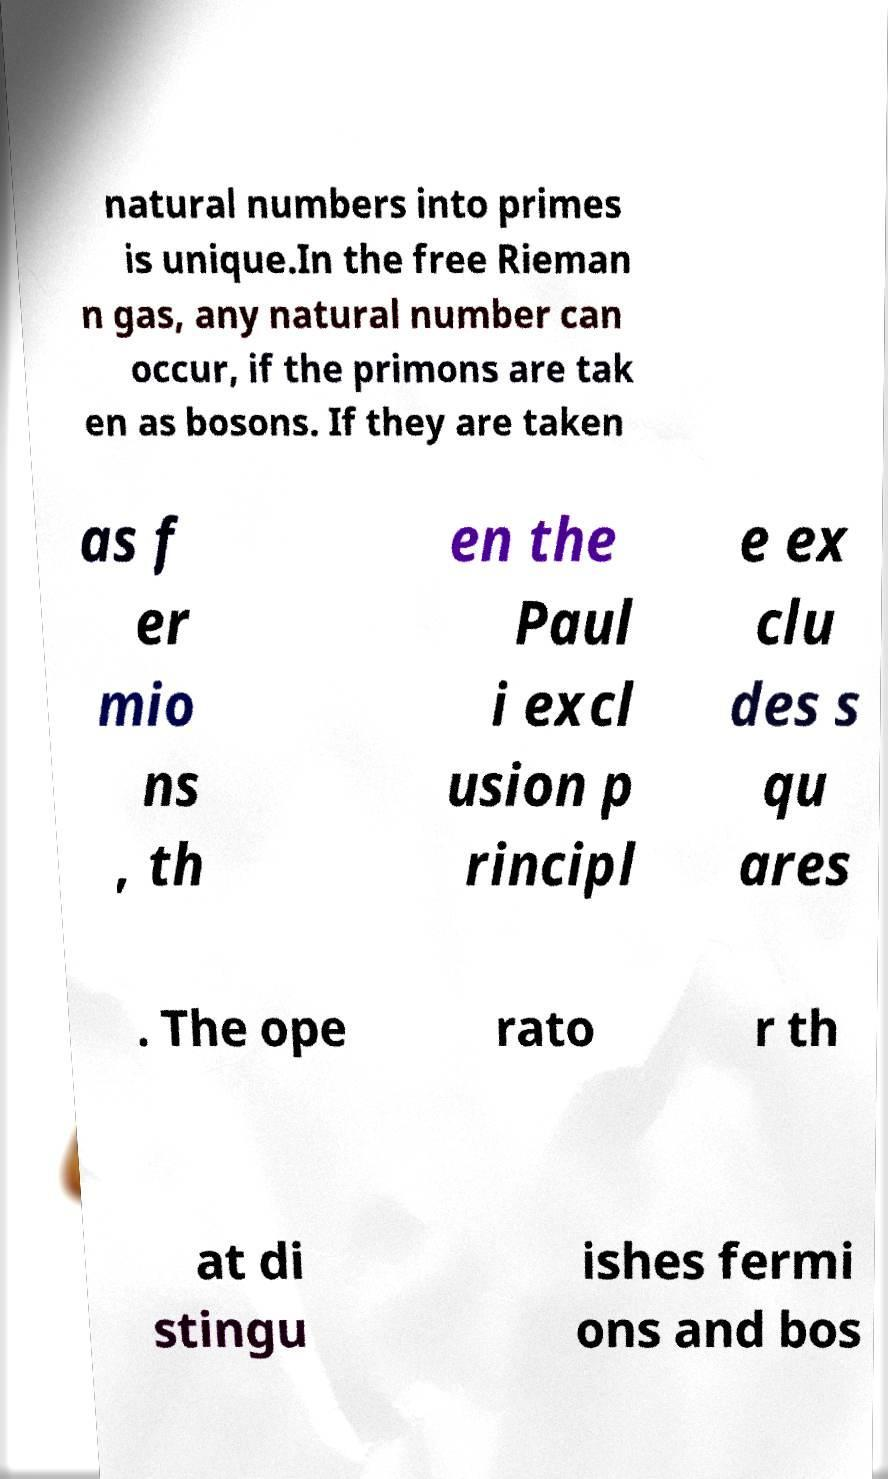What messages or text are displayed in this image? I need them in a readable, typed format. natural numbers into primes is unique.In the free Rieman n gas, any natural number can occur, if the primons are tak en as bosons. If they are taken as f er mio ns , th en the Paul i excl usion p rincipl e ex clu des s qu ares . The ope rato r th at di stingu ishes fermi ons and bos 